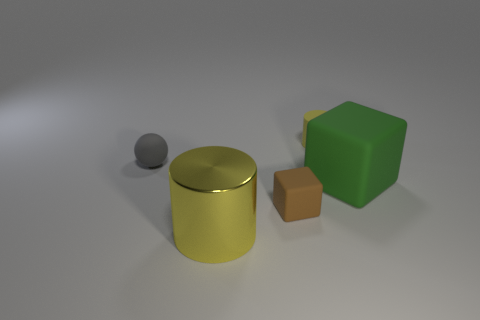Add 5 gray rubber objects. How many objects exist? 10 Subtract all blocks. How many objects are left? 3 Add 4 large matte things. How many large matte things exist? 5 Subtract 0 green spheres. How many objects are left? 5 Subtract all big yellow cylinders. Subtract all small brown blocks. How many objects are left? 3 Add 4 metallic objects. How many metallic objects are left? 5 